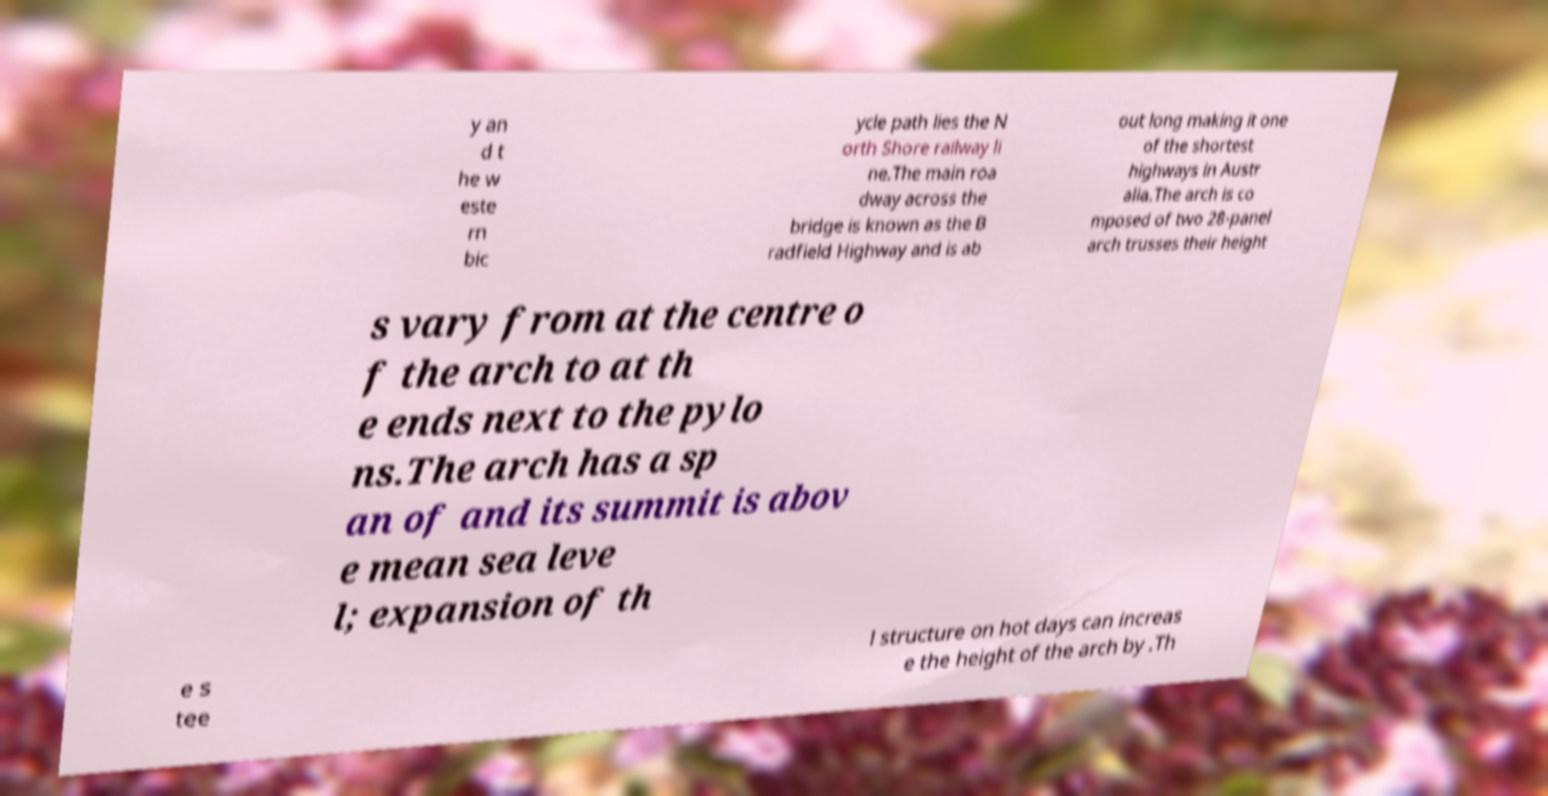Please identify and transcribe the text found in this image. y an d t he w este rn bic ycle path lies the N orth Shore railway li ne.The main roa dway across the bridge is known as the B radfield Highway and is ab out long making it one of the shortest highways in Austr alia.The arch is co mposed of two 28-panel arch trusses their height s vary from at the centre o f the arch to at th e ends next to the pylo ns.The arch has a sp an of and its summit is abov e mean sea leve l; expansion of th e s tee l structure on hot days can increas e the height of the arch by .Th 